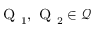<formula> <loc_0><loc_0><loc_500><loc_500>{ Q } _ { 1 } , { Q } _ { 2 } \in { \mathcal { Q } }</formula> 